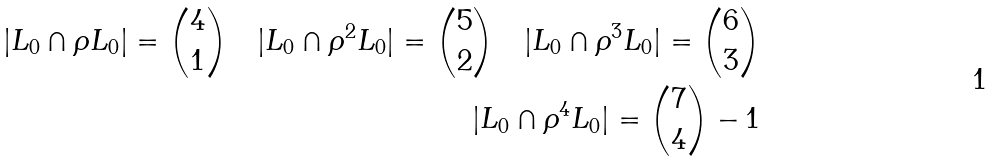<formula> <loc_0><loc_0><loc_500><loc_500>| L _ { 0 } \cap \rho L _ { 0 } | = \binom { 4 } { 1 } \quad | L _ { 0 } \cap \rho ^ { 2 } L _ { 0 } | = \binom { 5 } { 2 } \quad | L _ { 0 } \cap \rho ^ { 3 } L _ { 0 } | = \binom { 6 } { 3 } \\ | L _ { 0 } \cap \rho ^ { 4 } L _ { 0 } | = \binom { 7 } { 4 } - 1</formula> 